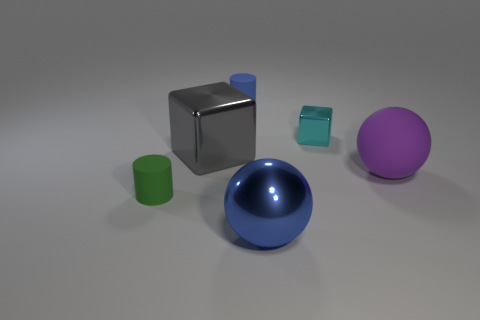Is the number of big metal cubes behind the small metal cube less than the number of big red blocks?
Provide a succinct answer. No. What is the color of the other tiny cube that is made of the same material as the gray block?
Your answer should be very brief. Cyan. There is a matte cylinder behind the green thing; what size is it?
Ensure brevity in your answer.  Small. Is the material of the cyan cube the same as the blue sphere?
Your response must be concise. Yes. There is a small cylinder that is on the left side of the tiny cylinder behind the tiny shiny object; are there any purple things on the right side of it?
Offer a very short reply. Yes. What is the color of the big block?
Your answer should be compact. Gray. What is the color of the metal block that is the same size as the green matte cylinder?
Provide a short and direct response. Cyan. Do the blue object behind the large purple matte sphere and the green object have the same shape?
Your response must be concise. Yes. There is a cylinder that is to the left of the rubber cylinder right of the tiny cylinder in front of the purple sphere; what is its color?
Your answer should be compact. Green. Are any tiny gray rubber cylinders visible?
Your response must be concise. No. 